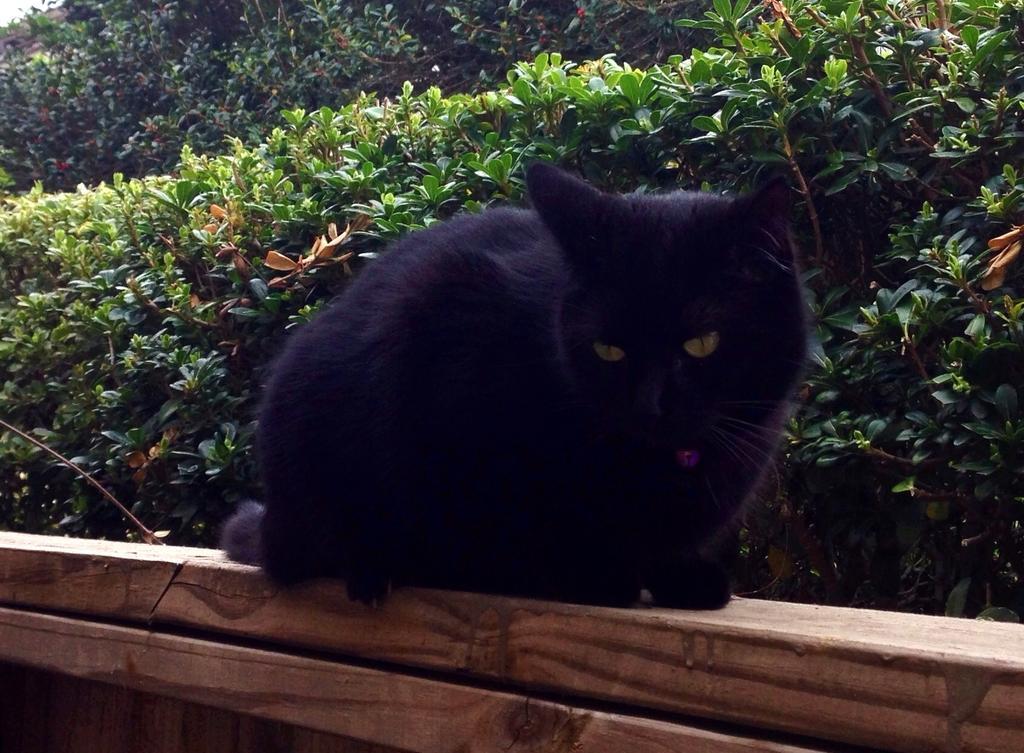Could you give a brief overview of what you see in this image? In the center of the image, we can see a cat on the wooden fence and in the background, there are trees. 